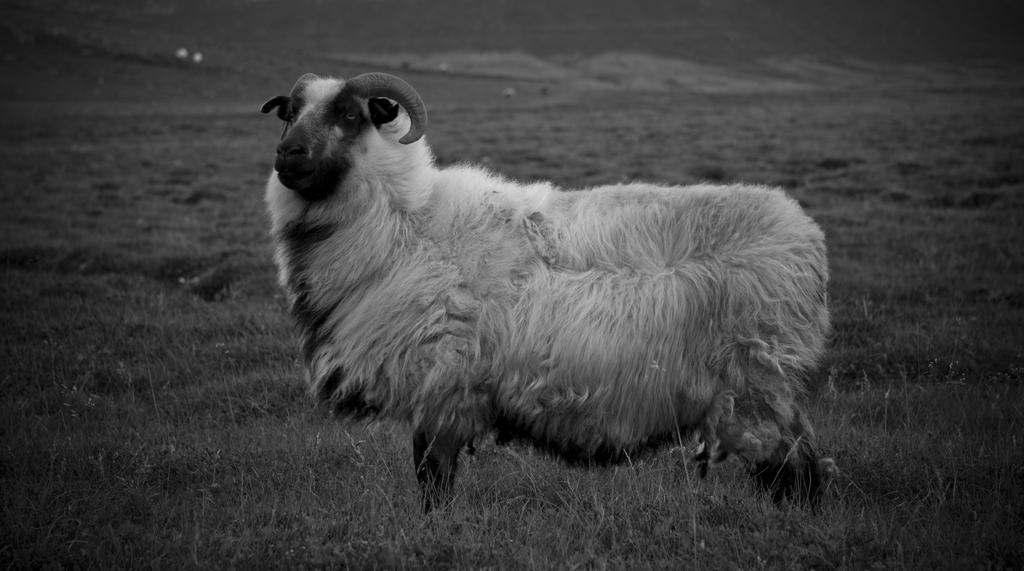What is the main subject of the image? There is a sheep in the center of the image. What type of vegetation can be seen at the bottom of the image? There is grass visible at the bottom of the image. What type of dolls are made of copper in the image? There are no dolls or copper objects present in the image. 